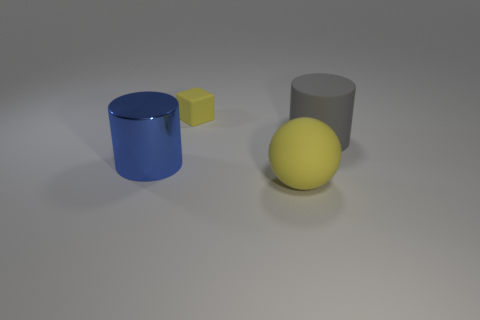Add 2 big matte spheres. How many objects exist? 6 Subtract all brown balls. Subtract all gray cubes. How many balls are left? 1 Subtract all purple cubes. How many yellow cylinders are left? 0 Subtract all green metal cylinders. Subtract all yellow objects. How many objects are left? 2 Add 4 gray cylinders. How many gray cylinders are left? 5 Add 3 spheres. How many spheres exist? 4 Subtract 0 brown cylinders. How many objects are left? 4 